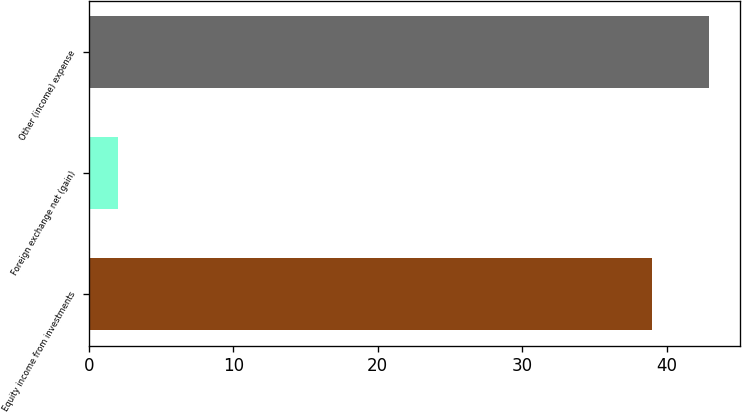Convert chart to OTSL. <chart><loc_0><loc_0><loc_500><loc_500><bar_chart><fcel>Equity income from investments<fcel>Foreign exchange net (gain)<fcel>Other (income) expense<nl><fcel>39<fcel>2<fcel>42.9<nl></chart> 